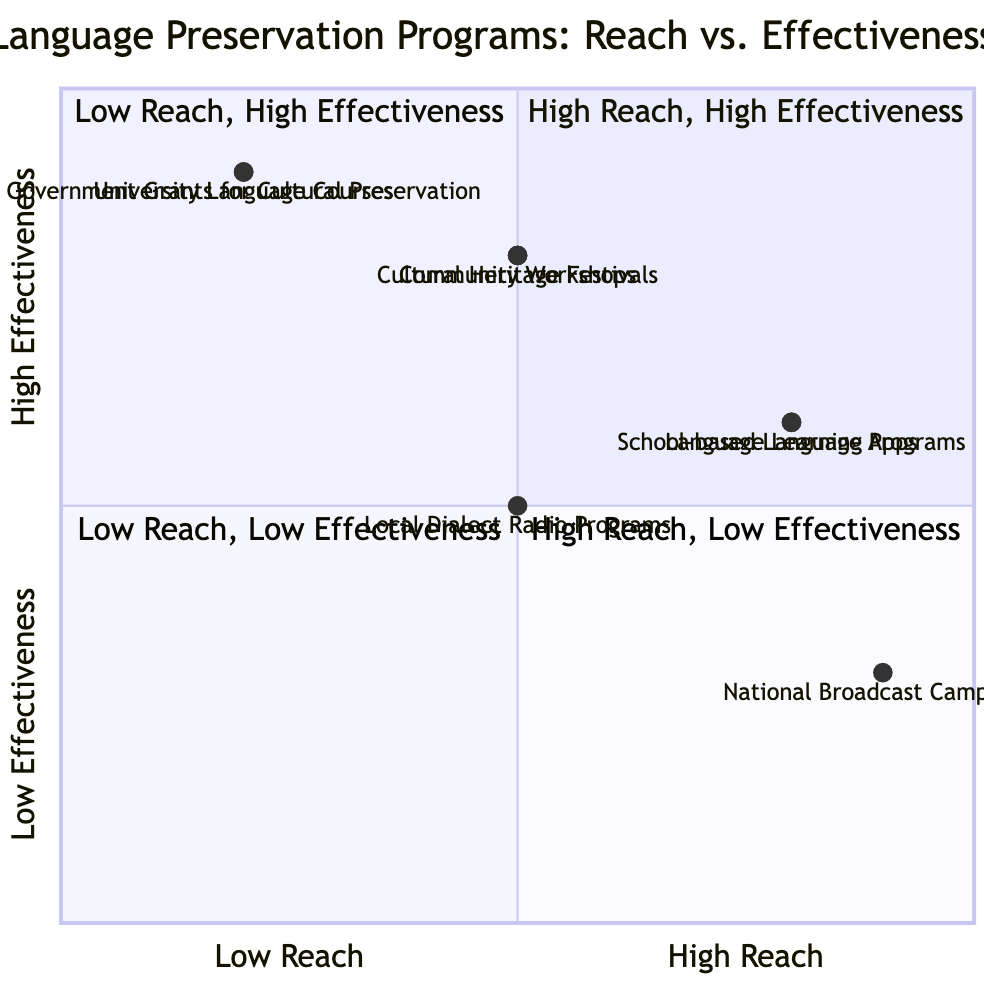What's the total number of language programs represented in the diagram? There are 8 language programs listed in the diagram: School-based Language Programs, Community Workshops, National Broadcast Campaigns, Language Learning Apps, Cultural Heritage Festivals, University Language Courses, Local Dialect Radio Programs, and Government Grants for Cultural Preservation.
Answer: 8 Which program has the highest reach? National Broadcast Campaigns, School-based Language Programs, and Language Learning Apps all have high reach based on the diagram. Each of these programs is positioned in the "High Reach" section of the x-axis.
Answer: National Broadcast Campaigns, School-based Language Programs, Language Learning Apps What is the effectiveness rating of the Community Workshops? The Community Workshops are positioned in the diagram at a y-axis value indicating a high effectiveness, specifically in the quadrant that corresponds to moderate reach and high effectiveness.
Answer: High Which quadrant contains the School-based Language Programs? The School-based Language Programs are in quadrant 4, where programs with high reach are shown to have low effectiveness, as indicated by its position on the x-axis and y-axis.
Answer: Quadrant 4 How many programs have low reach and high effectiveness? There are 2 programs that have low reach but high effectiveness based on their positions in the diagram: University Language Courses and Government Grants for Cultural Preservation.
Answer: 2 Which program is in the same quadrant as the Cultural Heritage Festivals but has a different reach? The Community Workshops are in the same quadrant (quadrant 1) as the Cultural Heritage Festivals; however, they have a moderate reach while the Cultural Heritage Festivals have a moderate reach as well. The key difference lies in their respective effectiveness levels.
Answer: Community Workshops What is the effectiveness of University Language Courses? According to the diagram, University Language Courses are represented in the quadrant that corresponds to low reach but high effectiveness, indicating that it has a high effect despite its limited reach.
Answer: High Which language preservation program has the same effectiveness as Local Dialect Radio Programs? Local Dialect Radio Programs have a moderate effectiveness, which they share with School-based Language Programs and Language Learning Apps, as all three are positioned with the same y-value on the diagram.
Answer: School-based Language Programs, Language Learning Apps What does it indicate about the National Broadcast Campaigns in terms of effectiveness? National Broadcast Campaigns are in quadrant 4 where they demonstrate high reach but low effectiveness, indicating that while they reach a large audience, they are not effectively preserving the language.
Answer: Low 